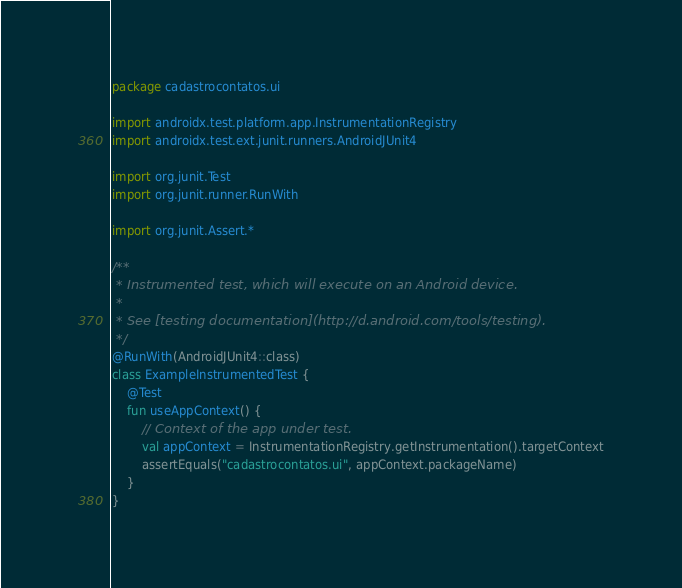Convert code to text. <code><loc_0><loc_0><loc_500><loc_500><_Kotlin_>package cadastrocontatos.ui

import androidx.test.platform.app.InstrumentationRegistry
import androidx.test.ext.junit.runners.AndroidJUnit4

import org.junit.Test
import org.junit.runner.RunWith

import org.junit.Assert.*

/**
 * Instrumented test, which will execute on an Android device.
 *
 * See [testing documentation](http://d.android.com/tools/testing).
 */
@RunWith(AndroidJUnit4::class)
class ExampleInstrumentedTest {
    @Test
    fun useAppContext() {
        // Context of the app under test.
        val appContext = InstrumentationRegistry.getInstrumentation().targetContext
        assertEquals("cadastrocontatos.ui", appContext.packageName)
    }
}</code> 